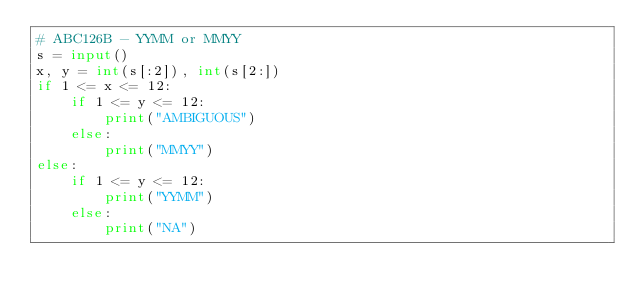<code> <loc_0><loc_0><loc_500><loc_500><_Python_># ABC126B - YYMM or MMYY
s = input()
x, y = int(s[:2]), int(s[2:])
if 1 <= x <= 12:
    if 1 <= y <= 12:
        print("AMBIGUOUS")
    else:
        print("MMYY")
else:
    if 1 <= y <= 12:
        print("YYMM")
    else:
        print("NA")</code> 